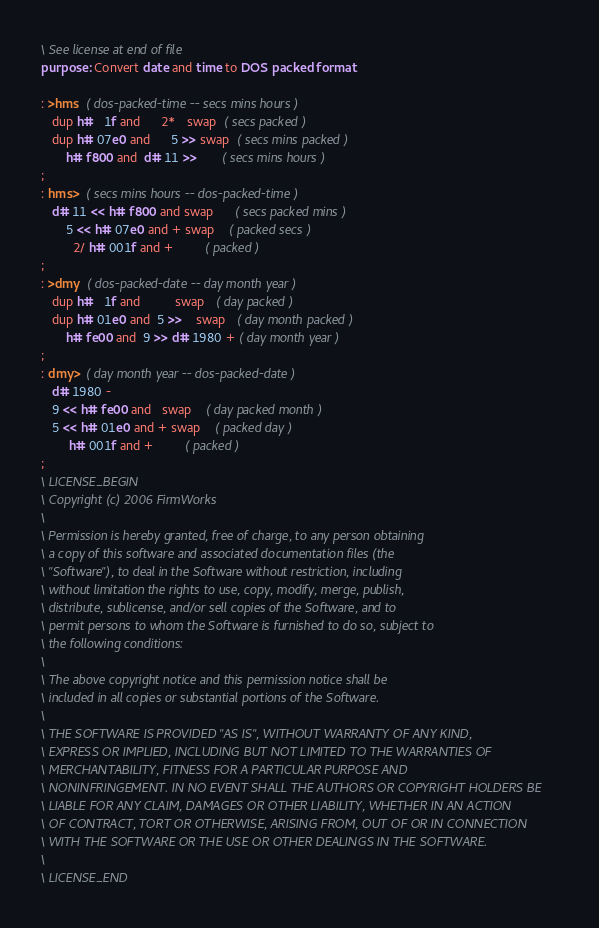Convert code to text. <code><loc_0><loc_0><loc_500><loc_500><_Forth_>\ See license at end of file
purpose: Convert date and time to DOS packed format

: >hms  ( dos-packed-time -- secs mins hours )
   dup h#   1f and      2*   swap  ( secs packed )
   dup h# 07e0 and      5 >> swap  ( secs mins packed )
       h# f800 and  d# 11 >>       ( secs mins hours )
;  
: hms>  ( secs mins hours -- dos-packed-time )
   d# 11 << h# f800 and swap      ( secs packed mins )
       5 << h# 07e0 and + swap    ( packed secs )
         2/ h# 001f and +         ( packed )
;
: >dmy  ( dos-packed-date -- day month year )
   dup h#   1f and          swap   ( day packed )
   dup h# 01e0 and  5 >>    swap   ( day month packed )
       h# fe00 and  9 >> d# 1980 + ( day month year )
;  
: dmy>  ( day month year -- dos-packed-date )
   d# 1980 -
   9 << h# fe00 and   swap    ( day packed month )
   5 << h# 01e0 and + swap    ( packed day )
        h# 001f and +         ( packed )
;
\ LICENSE_BEGIN
\ Copyright (c) 2006 FirmWorks
\ 
\ Permission is hereby granted, free of charge, to any person obtaining
\ a copy of this software and associated documentation files (the
\ "Software"), to deal in the Software without restriction, including
\ without limitation the rights to use, copy, modify, merge, publish,
\ distribute, sublicense, and/or sell copies of the Software, and to
\ permit persons to whom the Software is furnished to do so, subject to
\ the following conditions:
\ 
\ The above copyright notice and this permission notice shall be
\ included in all copies or substantial portions of the Software.
\ 
\ THE SOFTWARE IS PROVIDED "AS IS", WITHOUT WARRANTY OF ANY KIND,
\ EXPRESS OR IMPLIED, INCLUDING BUT NOT LIMITED TO THE WARRANTIES OF
\ MERCHANTABILITY, FITNESS FOR A PARTICULAR PURPOSE AND
\ NONINFRINGEMENT. IN NO EVENT SHALL THE AUTHORS OR COPYRIGHT HOLDERS BE
\ LIABLE FOR ANY CLAIM, DAMAGES OR OTHER LIABILITY, WHETHER IN AN ACTION
\ OF CONTRACT, TORT OR OTHERWISE, ARISING FROM, OUT OF OR IN CONNECTION
\ WITH THE SOFTWARE OR THE USE OR OTHER DEALINGS IN THE SOFTWARE.
\
\ LICENSE_END
</code> 